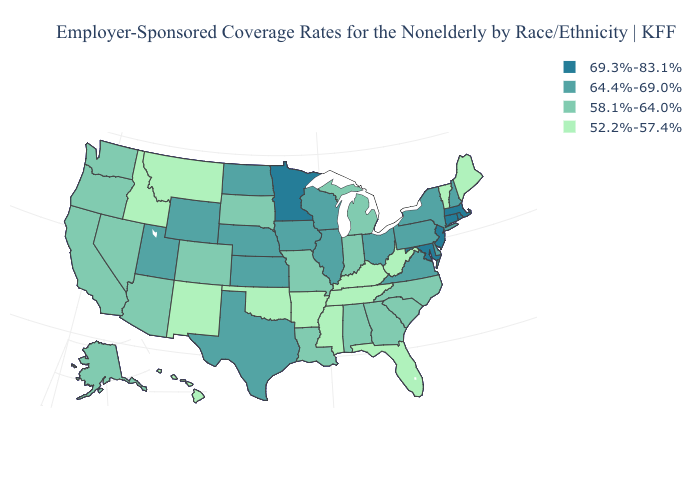Does the first symbol in the legend represent the smallest category?
Concise answer only. No. What is the value of Maryland?
Be succinct. 69.3%-83.1%. What is the highest value in the Northeast ?
Write a very short answer. 69.3%-83.1%. What is the value of Arizona?
Give a very brief answer. 58.1%-64.0%. Does the first symbol in the legend represent the smallest category?
Write a very short answer. No. Does the map have missing data?
Give a very brief answer. No. Does the map have missing data?
Be succinct. No. Among the states that border Oklahoma , which have the lowest value?
Quick response, please. Arkansas, New Mexico. What is the value of Maine?
Keep it brief. 52.2%-57.4%. Is the legend a continuous bar?
Write a very short answer. No. What is the value of Idaho?
Be succinct. 52.2%-57.4%. What is the value of Alaska?
Keep it brief. 58.1%-64.0%. Which states hav the highest value in the Northeast?
Keep it brief. Connecticut, Massachusetts, New Jersey, Rhode Island. What is the value of Vermont?
Short answer required. 52.2%-57.4%. Name the states that have a value in the range 52.2%-57.4%?
Short answer required. Arkansas, Florida, Hawaii, Idaho, Kentucky, Maine, Mississippi, Montana, New Mexico, Oklahoma, Tennessee, Vermont, West Virginia. 